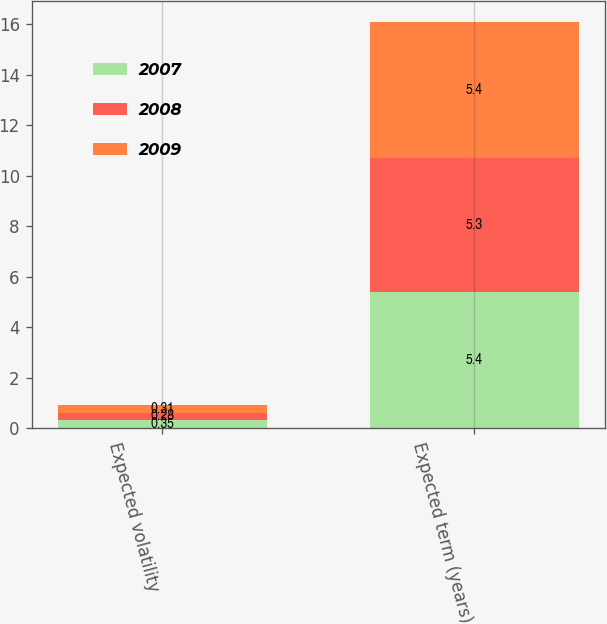<chart> <loc_0><loc_0><loc_500><loc_500><stacked_bar_chart><ecel><fcel>Expected volatility<fcel>Expected term (years)<nl><fcel>2007<fcel>0.35<fcel>5.4<nl><fcel>2008<fcel>0.28<fcel>5.3<nl><fcel>2009<fcel>0.31<fcel>5.4<nl></chart> 